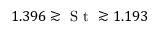<formula> <loc_0><loc_0><loc_500><loc_500>1 . 3 9 6 \gtrsim S t \gtrsim 1 . 1 9 3</formula> 